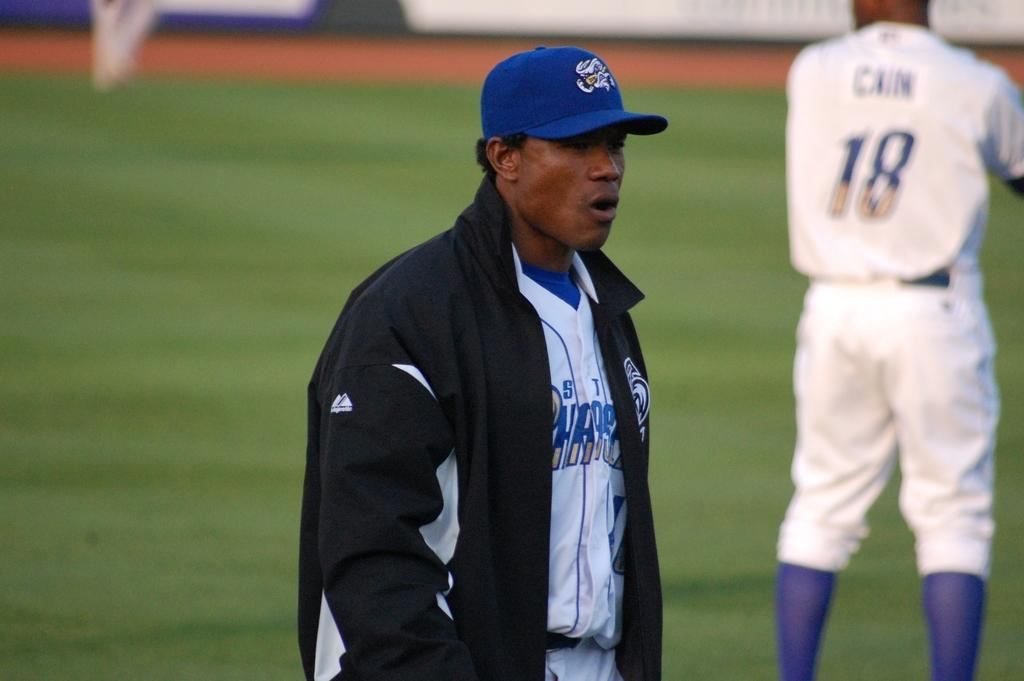<image>
Write a terse but informative summary of the picture. A baseball player with a white and blue uniform has the number 18 on his back. 